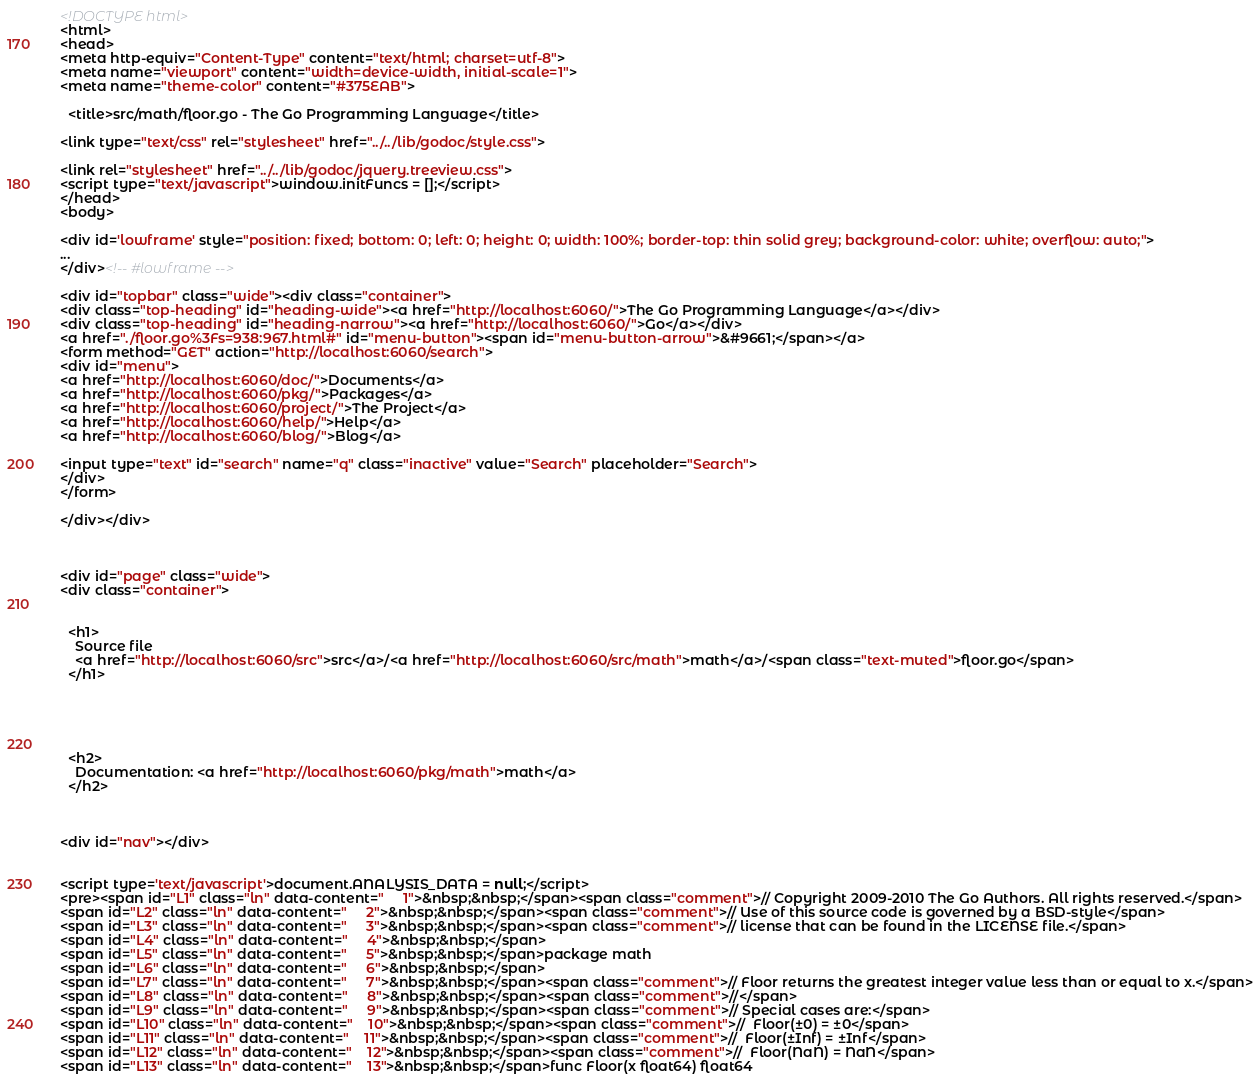<code> <loc_0><loc_0><loc_500><loc_500><_HTML_><!DOCTYPE html>
<html>
<head>
<meta http-equiv="Content-Type" content="text/html; charset=utf-8">
<meta name="viewport" content="width=device-width, initial-scale=1">
<meta name="theme-color" content="#375EAB">

  <title>src/math/floor.go - The Go Programming Language</title>

<link type="text/css" rel="stylesheet" href="../../lib/godoc/style.css">

<link rel="stylesheet" href="../../lib/godoc/jquery.treeview.css">
<script type="text/javascript">window.initFuncs = [];</script>
</head>
<body>

<div id='lowframe' style="position: fixed; bottom: 0; left: 0; height: 0; width: 100%; border-top: thin solid grey; background-color: white; overflow: auto;">
...
</div><!-- #lowframe -->

<div id="topbar" class="wide"><div class="container">
<div class="top-heading" id="heading-wide"><a href="http://localhost:6060/">The Go Programming Language</a></div>
<div class="top-heading" id="heading-narrow"><a href="http://localhost:6060/">Go</a></div>
<a href="./floor.go%3Fs=938:967.html#" id="menu-button"><span id="menu-button-arrow">&#9661;</span></a>
<form method="GET" action="http://localhost:6060/search">
<div id="menu">
<a href="http://localhost:6060/doc/">Documents</a>
<a href="http://localhost:6060/pkg/">Packages</a>
<a href="http://localhost:6060/project/">The Project</a>
<a href="http://localhost:6060/help/">Help</a>
<a href="http://localhost:6060/blog/">Blog</a>

<input type="text" id="search" name="q" class="inactive" value="Search" placeholder="Search">
</div>
</form>

</div></div>



<div id="page" class="wide">
<div class="container">


  <h1>
    Source file
    <a href="http://localhost:6060/src">src</a>/<a href="http://localhost:6060/src/math">math</a>/<span class="text-muted">floor.go</span>
  </h1>





  <h2>
    Documentation: <a href="http://localhost:6060/pkg/math">math</a>
  </h2>



<div id="nav"></div>


<script type='text/javascript'>document.ANALYSIS_DATA = null;</script>
<pre><span id="L1" class="ln" data-content="     1">&nbsp;&nbsp;</span><span class="comment">// Copyright 2009-2010 The Go Authors. All rights reserved.</span>
<span id="L2" class="ln" data-content="     2">&nbsp;&nbsp;</span><span class="comment">// Use of this source code is governed by a BSD-style</span>
<span id="L3" class="ln" data-content="     3">&nbsp;&nbsp;</span><span class="comment">// license that can be found in the LICENSE file.</span>
<span id="L4" class="ln" data-content="     4">&nbsp;&nbsp;</span>
<span id="L5" class="ln" data-content="     5">&nbsp;&nbsp;</span>package math
<span id="L6" class="ln" data-content="     6">&nbsp;&nbsp;</span>
<span id="L7" class="ln" data-content="     7">&nbsp;&nbsp;</span><span class="comment">// Floor returns the greatest integer value less than or equal to x.</span>
<span id="L8" class="ln" data-content="     8">&nbsp;&nbsp;</span><span class="comment">//</span>
<span id="L9" class="ln" data-content="     9">&nbsp;&nbsp;</span><span class="comment">// Special cases are:</span>
<span id="L10" class="ln" data-content="    10">&nbsp;&nbsp;</span><span class="comment">//	Floor(±0) = ±0</span>
<span id="L11" class="ln" data-content="    11">&nbsp;&nbsp;</span><span class="comment">//	Floor(±Inf) = ±Inf</span>
<span id="L12" class="ln" data-content="    12">&nbsp;&nbsp;</span><span class="comment">//	Floor(NaN) = NaN</span>
<span id="L13" class="ln" data-content="    13">&nbsp;&nbsp;</span>func Floor(x float64) float64</code> 